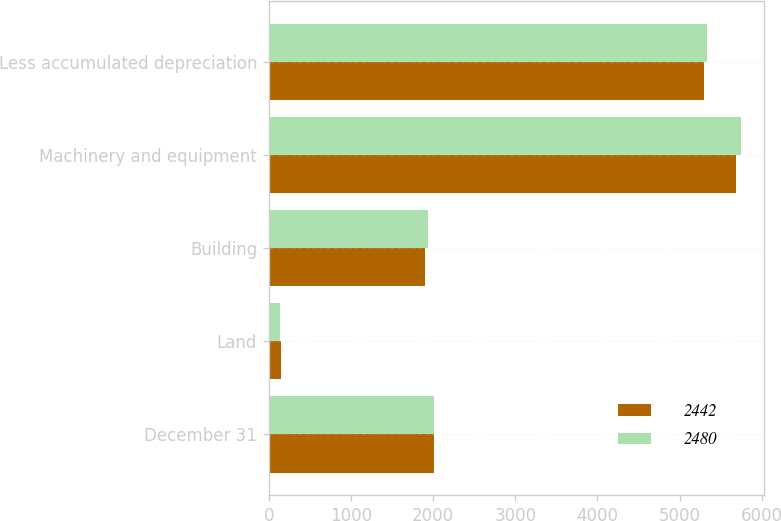Convert chart to OTSL. <chart><loc_0><loc_0><loc_500><loc_500><stacked_bar_chart><ecel><fcel>December 31<fcel>Land<fcel>Building<fcel>Machinery and equipment<fcel>Less accumulated depreciation<nl><fcel>2442<fcel>2008<fcel>148<fcel>1905<fcel>5687<fcel>5298<nl><fcel>2480<fcel>2007<fcel>134<fcel>1934<fcel>5745<fcel>5333<nl></chart> 